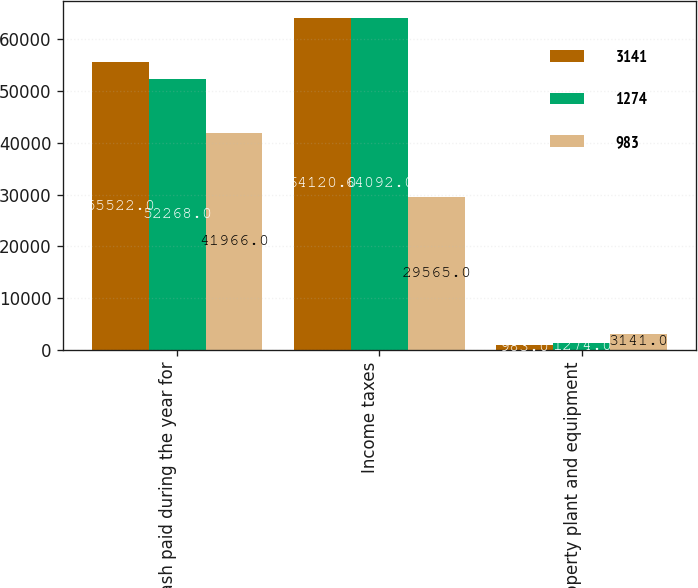Convert chart. <chart><loc_0><loc_0><loc_500><loc_500><stacked_bar_chart><ecel><fcel>Cash paid during the year for<fcel>Income taxes<fcel>Property plant and equipment<nl><fcel>3141<fcel>55522<fcel>64120<fcel>983<nl><fcel>1274<fcel>52268<fcel>64092<fcel>1274<nl><fcel>983<fcel>41966<fcel>29565<fcel>3141<nl></chart> 